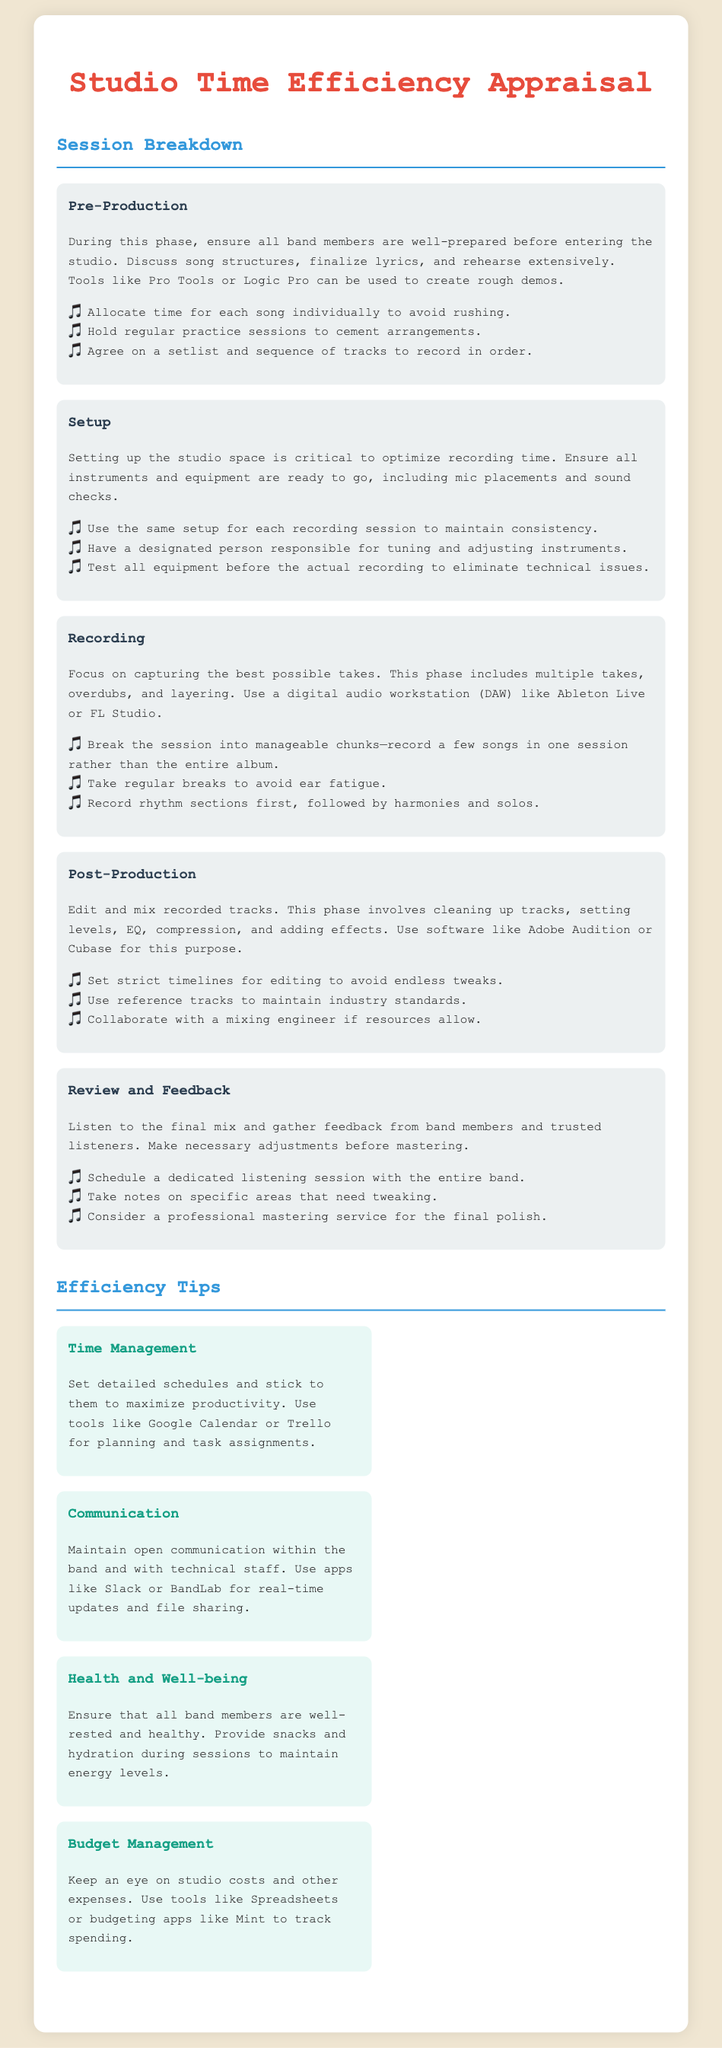What is the first phase of the session breakdown? The first phase of the session breakdown is outlined in the document as Pre-Production.
Answer: Pre-Production What software is mentioned for post-production? The document mentions Adobe Audition or Cubase for post-production efforts.
Answer: Adobe Audition or Cubase How many suggestions are provided for the Setup phase? The Setup phase includes three suggestions listed in the document.
Answer: Three What is one of the efficiency tips related to health? The document includes health-related tips that emphasize ensuring all band members are well-rested and providing snacks.
Answer: Health and well-being Which tool is suggested for time management? Google Calendar is identified in the document as a tool for managing time efficiently.
Answer: Google Calendar What percentage of the document focuses on Session Breakdown? The document contains five sections for Session Breakdown, while there are four efficiency tips in a separate section, indicating a majority focus on the session aspects.
Answer: Majority What is advised to improve communication among band members? The document recommends using apps like Slack or BandLab for improved communication.
Answer: Slack or BandLab What type of service is recommended for final polishing? The document suggests considering a professional mastering service for the final polish of the music tracks.
Answer: Professional mastering service 